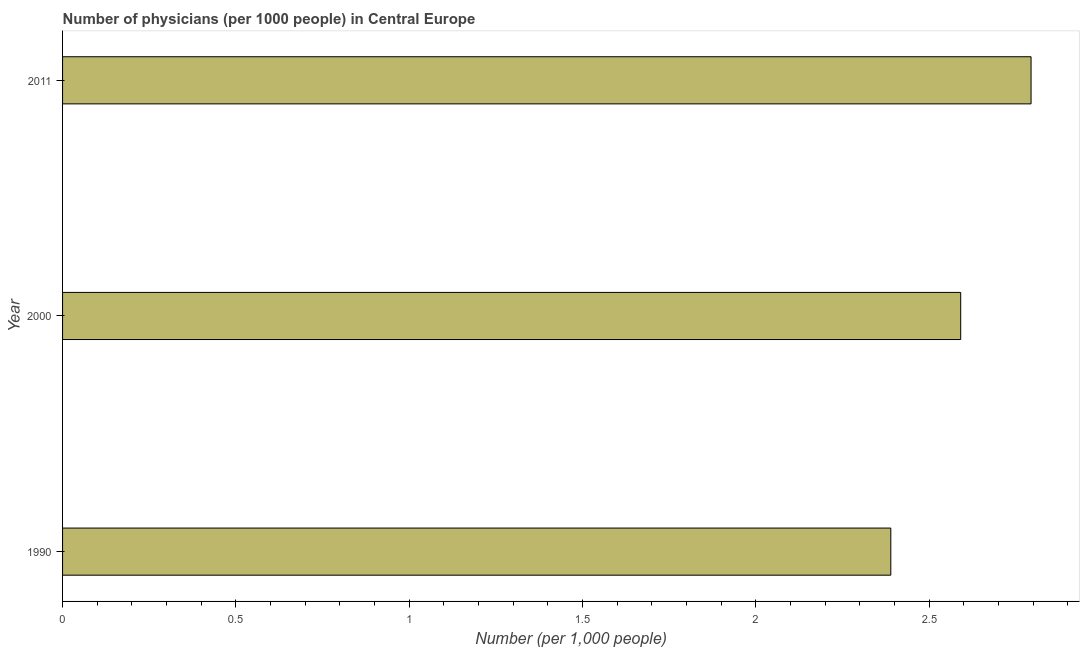Does the graph contain any zero values?
Your answer should be compact. No. Does the graph contain grids?
Your response must be concise. No. What is the title of the graph?
Provide a short and direct response. Number of physicians (per 1000 people) in Central Europe. What is the label or title of the X-axis?
Give a very brief answer. Number (per 1,0 people). What is the label or title of the Y-axis?
Provide a short and direct response. Year. What is the number of physicians in 2000?
Keep it short and to the point. 2.59. Across all years, what is the maximum number of physicians?
Give a very brief answer. 2.79. Across all years, what is the minimum number of physicians?
Offer a very short reply. 2.39. In which year was the number of physicians maximum?
Provide a succinct answer. 2011. In which year was the number of physicians minimum?
Make the answer very short. 1990. What is the sum of the number of physicians?
Ensure brevity in your answer.  7.77. What is the difference between the number of physicians in 2000 and 2011?
Provide a succinct answer. -0.2. What is the average number of physicians per year?
Keep it short and to the point. 2.59. What is the median number of physicians?
Offer a terse response. 2.59. In how many years, is the number of physicians greater than 0.4 ?
Keep it short and to the point. 3. Do a majority of the years between 2000 and 2011 (inclusive) have number of physicians greater than 0.1 ?
Give a very brief answer. Yes. What is the ratio of the number of physicians in 1990 to that in 2011?
Your answer should be compact. 0.85. Is the number of physicians in 2000 less than that in 2011?
Make the answer very short. Yes. Is the difference between the number of physicians in 1990 and 2011 greater than the difference between any two years?
Provide a succinct answer. Yes. What is the difference between the highest and the second highest number of physicians?
Provide a short and direct response. 0.2. Is the sum of the number of physicians in 2000 and 2011 greater than the maximum number of physicians across all years?
Offer a terse response. Yes. What is the difference between the highest and the lowest number of physicians?
Provide a succinct answer. 0.4. In how many years, is the number of physicians greater than the average number of physicians taken over all years?
Provide a succinct answer. 1. How many bars are there?
Provide a succinct answer. 3. Are all the bars in the graph horizontal?
Offer a terse response. Yes. What is the difference between two consecutive major ticks on the X-axis?
Make the answer very short. 0.5. What is the Number (per 1,000 people) in 1990?
Your answer should be very brief. 2.39. What is the Number (per 1,000 people) in 2000?
Provide a short and direct response. 2.59. What is the Number (per 1,000 people) of 2011?
Your answer should be very brief. 2.79. What is the difference between the Number (per 1,000 people) in 1990 and 2000?
Your answer should be very brief. -0.2. What is the difference between the Number (per 1,000 people) in 1990 and 2011?
Make the answer very short. -0.4. What is the difference between the Number (per 1,000 people) in 2000 and 2011?
Provide a succinct answer. -0.2. What is the ratio of the Number (per 1,000 people) in 1990 to that in 2000?
Offer a terse response. 0.92. What is the ratio of the Number (per 1,000 people) in 1990 to that in 2011?
Provide a succinct answer. 0.85. What is the ratio of the Number (per 1,000 people) in 2000 to that in 2011?
Provide a succinct answer. 0.93. 